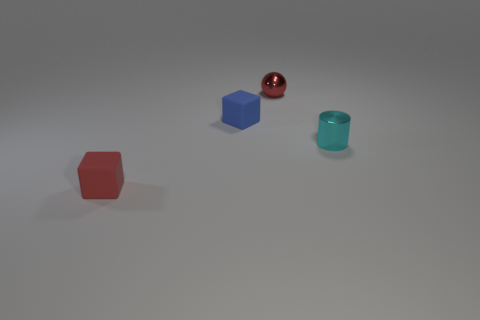Add 1 tiny red objects. How many objects exist? 5 Subtract all spheres. How many objects are left? 3 Subtract all red shiny objects. Subtract all big cyan metal spheres. How many objects are left? 3 Add 2 red metal objects. How many red metal objects are left? 3 Add 4 tiny green rubber things. How many tiny green rubber things exist? 4 Subtract 0 brown cubes. How many objects are left? 4 